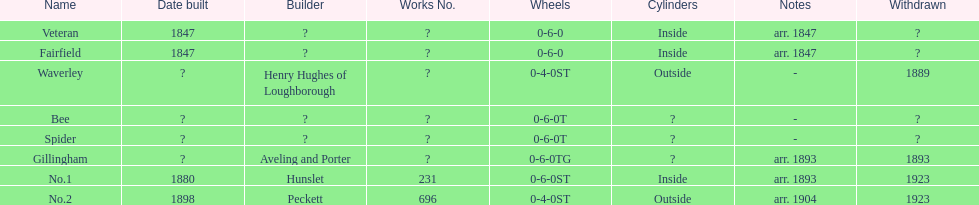What designation follows fairfield? Waverley. Can you give me this table as a dict? {'header': ['Name', 'Date built', 'Builder', 'Works No.', 'Wheels', 'Cylinders', 'Notes', 'Withdrawn'], 'rows': [['Veteran', '1847', '?', '?', '0-6-0', 'Inside', 'arr. 1847', '?'], ['Fairfield', '1847', '?', '?', '0-6-0', 'Inside', 'arr. 1847', '?'], ['Waverley', '?', 'Henry Hughes of Loughborough', '?', '0-4-0ST', 'Outside', '-', '1889'], ['Bee', '?', '?', '?', '0-6-0T', '?', '-', '?'], ['Spider', '?', '?', '?', '0-6-0T', '?', '-', '?'], ['Gillingham', '?', 'Aveling and Porter', '?', '0-6-0TG', '?', 'arr. 1893', '1893'], ['No.1', '1880', 'Hunslet', '231', '0-6-0ST', 'Inside', 'arr. 1893', '1923'], ['No.2', '1898', 'Peckett', '696', '0-4-0ST', 'Outside', 'arr. 1904', '1923']]} 